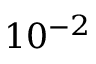Convert formula to latex. <formula><loc_0><loc_0><loc_500><loc_500>1 0 ^ { - 2 }</formula> 